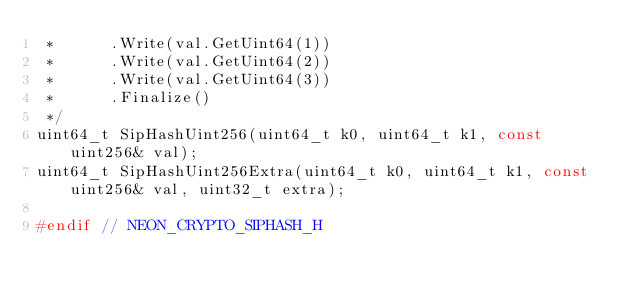<code> <loc_0><loc_0><loc_500><loc_500><_C_> *      .Write(val.GetUint64(1))
 *      .Write(val.GetUint64(2))
 *      .Write(val.GetUint64(3))
 *      .Finalize()
 */
uint64_t SipHashUint256(uint64_t k0, uint64_t k1, const uint256& val);
uint64_t SipHashUint256Extra(uint64_t k0, uint64_t k1, const uint256& val, uint32_t extra);

#endif // NEON_CRYPTO_SIPHASH_H
</code> 